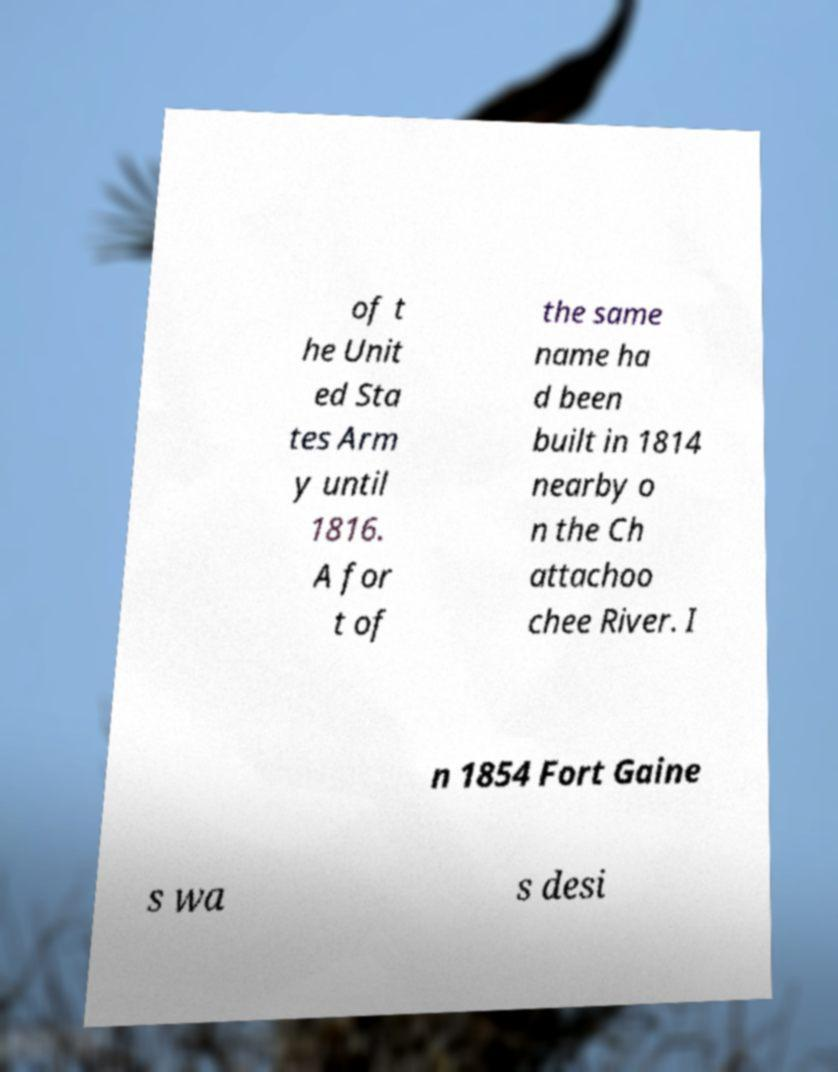For documentation purposes, I need the text within this image transcribed. Could you provide that? of t he Unit ed Sta tes Arm y until 1816. A for t of the same name ha d been built in 1814 nearby o n the Ch attachoo chee River. I n 1854 Fort Gaine s wa s desi 